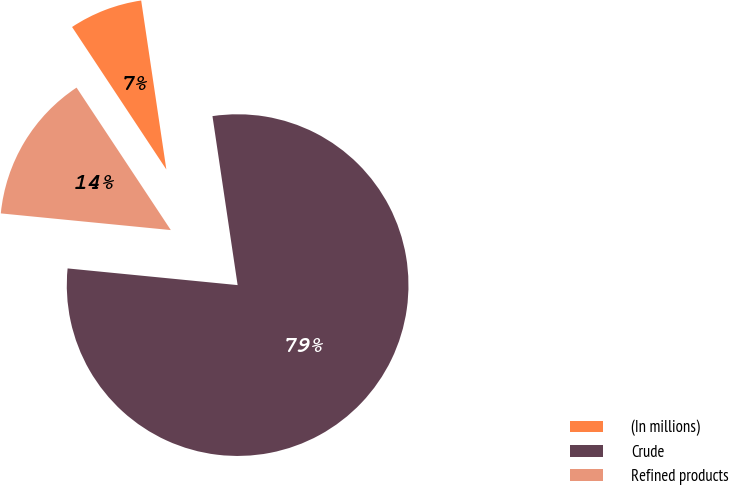Convert chart. <chart><loc_0><loc_0><loc_500><loc_500><pie_chart><fcel>(In millions)<fcel>Crude<fcel>Refined products<nl><fcel>6.95%<fcel>78.91%<fcel>14.14%<nl></chart> 